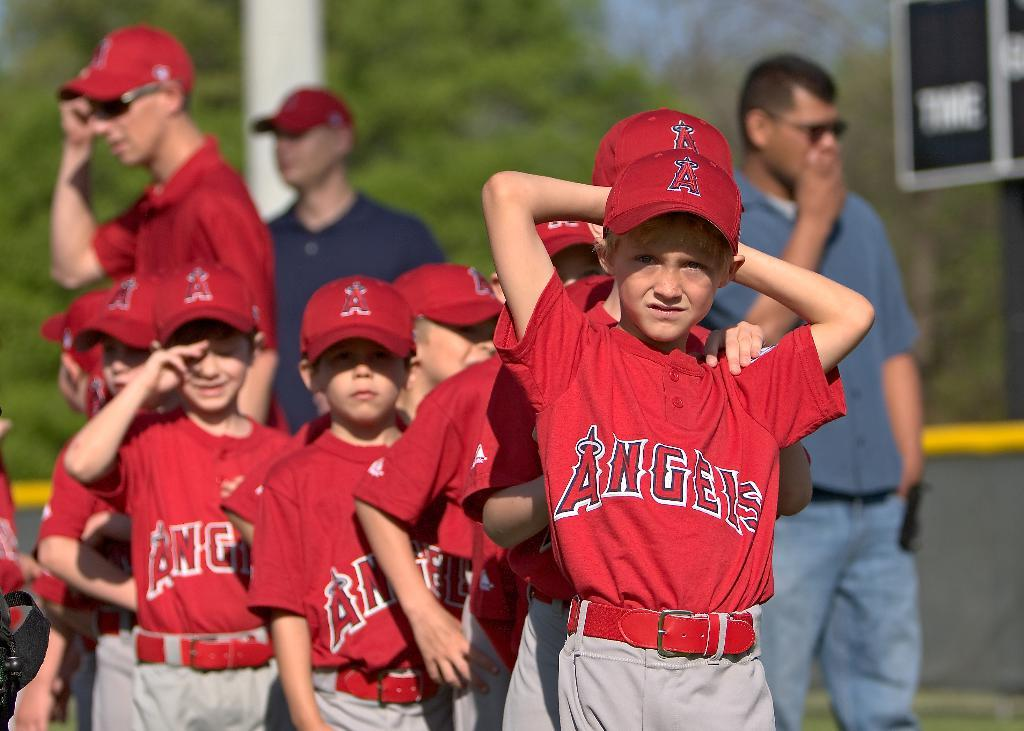<image>
Offer a succinct explanation of the picture presented. A group of Angels little league players stand in a line. 